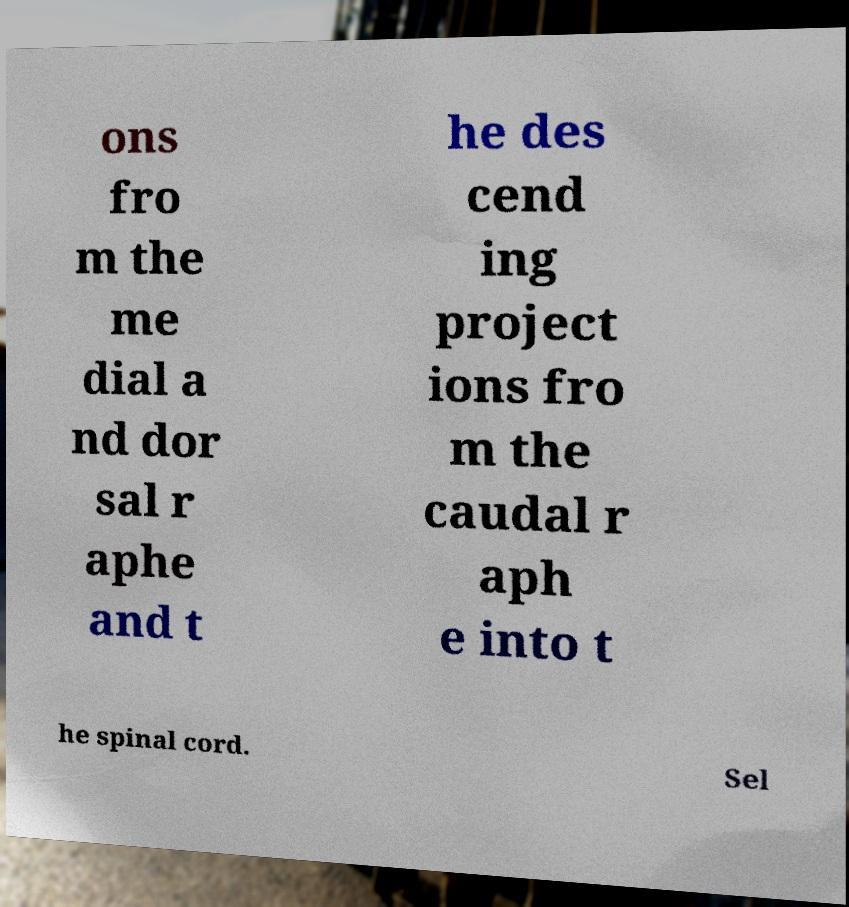What messages or text are displayed in this image? I need them in a readable, typed format. ons fro m the me dial a nd dor sal r aphe and t he des cend ing project ions fro m the caudal r aph e into t he spinal cord. Sel 